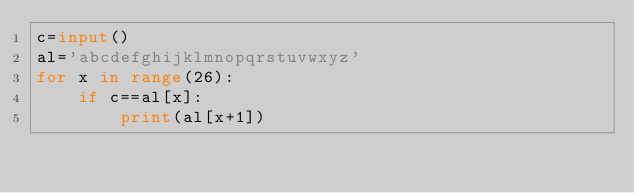<code> <loc_0><loc_0><loc_500><loc_500><_Python_>c=input()
al='abcdefghijklmnopqrstuvwxyz'
for x in range(26):
    if c==al[x]:
        print(al[x+1])</code> 